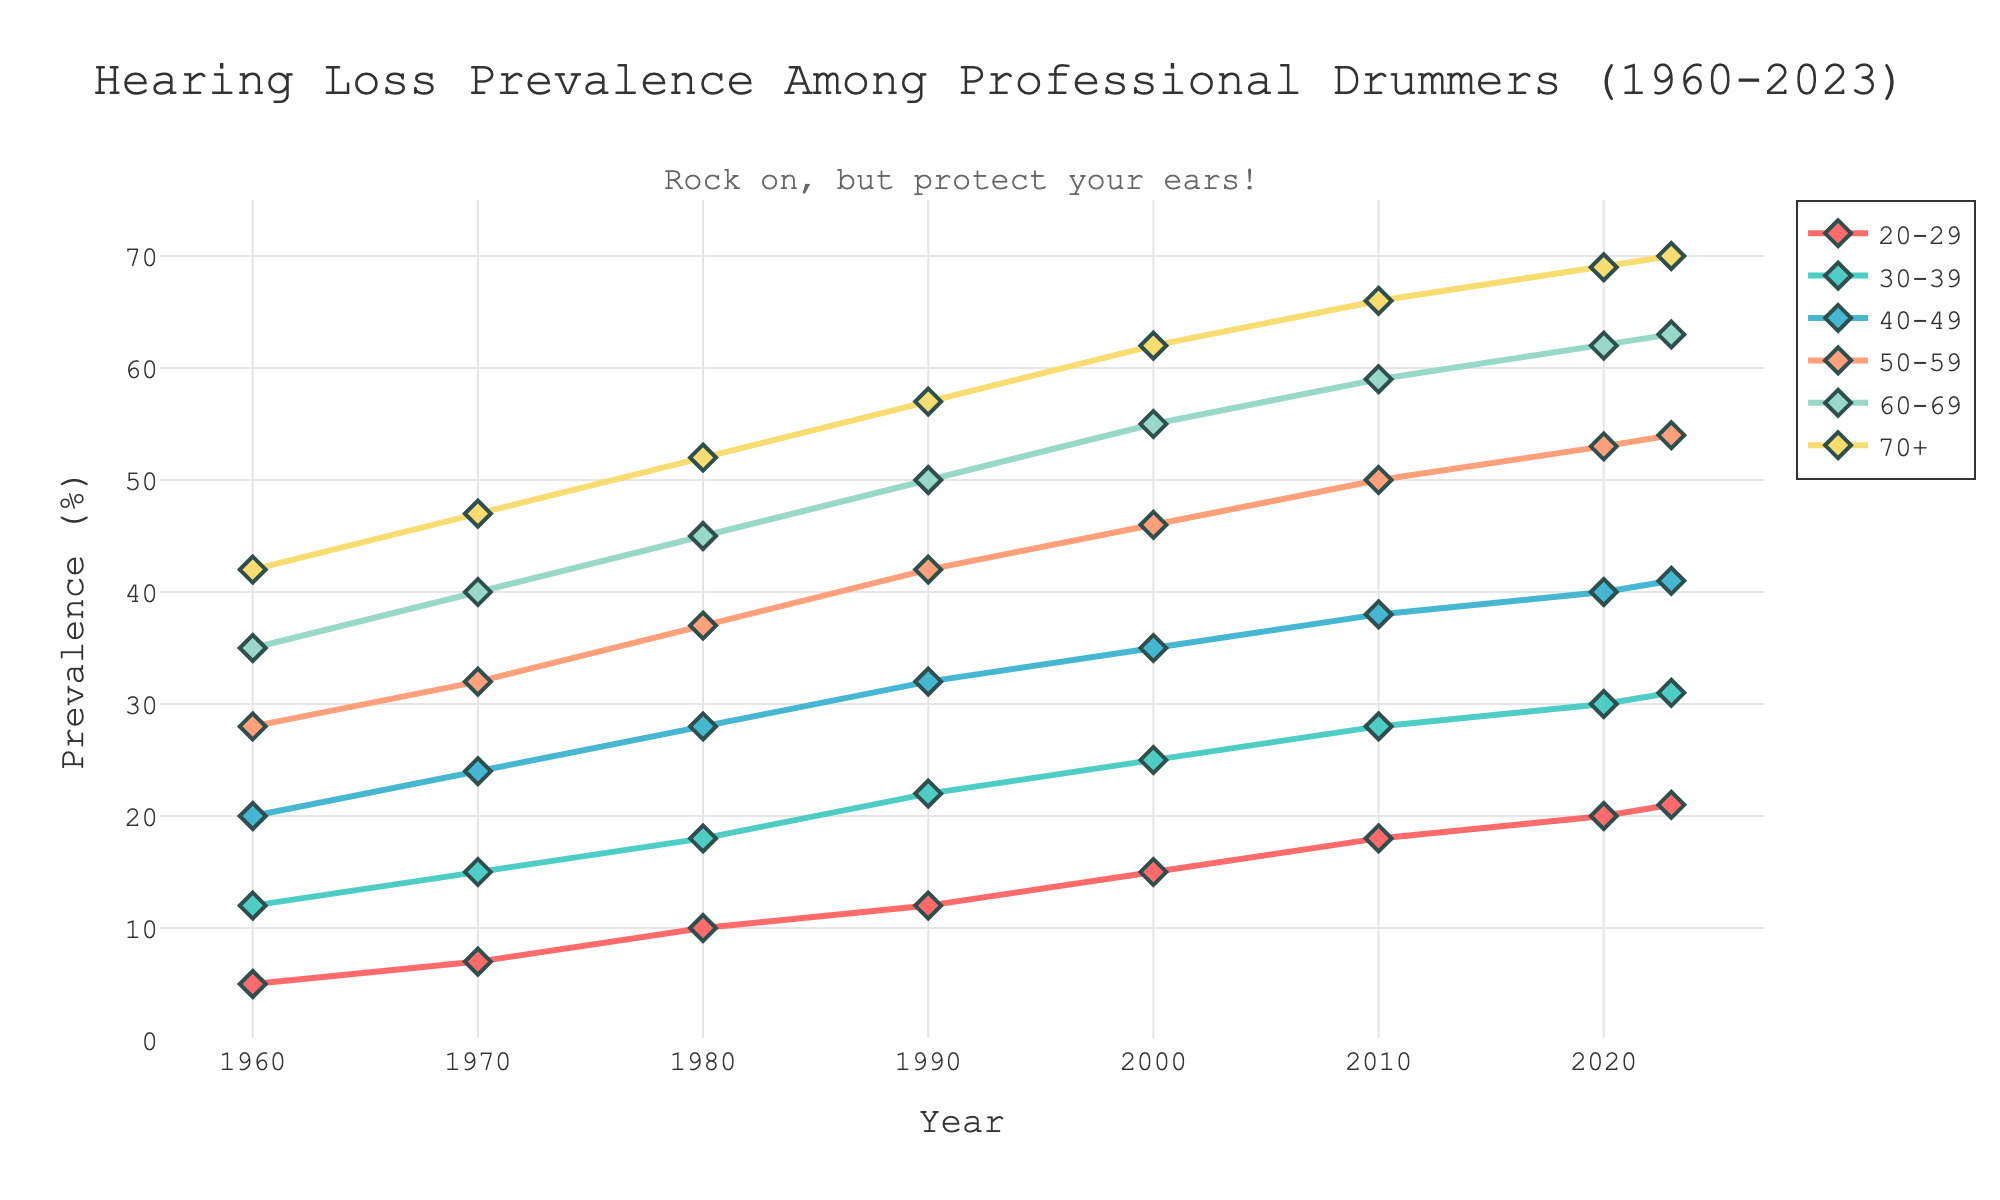How has the prevalence of hearing loss among professional drummers aged 40-49 changed from 1960 to 2023? Observing the line for the age group 40-49, in 1960, the prevalence was 20%. By 2023, it increased to 41%. The change is 41% - 20% = 21%.
Answer: Increased by 21% In which year did professional drummers aged 30-39 experience a prevalence of hearing loss of 25%? Looking at the plot, the data point for 30-39 indicates 25% in the year 2000.
Answer: 2000 Which age group has the highest prevalence of hearing loss in 2023? The points representing data for 2023 indicate that the age group 70+ has the highest prevalence at 70%.
Answer: 70+ What is the difference in the prevalence of hearing loss between the 20-29 and 60-69 age groups in 2010? From the plot, the prevalence for 20-29 in 2010 is 18%, and for 60-69, it is 59%. The difference is 59% - 18% = 41%.
Answer: 41% What is the average prevalence of hearing loss for the age group 50-59 from 1960 to 2023? Using the data: (28+32+37+42+46+50+53+54)/8 = 342/8 = 42.75.
Answer: 42.75% Compare the prevalence of hearing loss among professional drummers aged 40-49 and 50-59 in 1980. Which group had higher prevalence and by how much? In 1980, the prevalence for 40-49 was 28% and for 50-59 was 37%. The group 50-59 had a higher prevalence by 37% - 28% = 9%.
Answer: 50-59 by 9% Which age group has shown the most significant increase in hearing loss prevalence from 1960 to 2023, and what is the increase? Calculating for each group:
- 20-29: 21% - 5% = 16%
- 30-39: 31% - 12% = 19%
- 40-49: 41% - 20% = 21%
- 50-59: 54% - 28% = 26%
- 60-69: 63% - 35% = 28% 
- 70+: 70% - 42% = 28%
The age groups 60-69 and 70+ have the most significant increase at 28%.
Answer: 60-69 and 70+ by 28% During which decade did the age group 70+ experience the most substantial increase in hearing loss prevalence? By checking the increments: 
- 1960 to 1970: 47% - 42% = 5%
- 1970 to 1980: 52% - 47% = 5%
- 1980 to 1990: 57% - 52% = 5%
- 1990 to 2000: 62% - 57% = 5%
- 2000 to 2010: 66% - 62% = 4%
- 2010 to 2020: 69% - 66% = 3%
- 2020 to 2023: 70% - 69% = 1%
The increases are primarily equal, except 2000-2010 has a 4% increase.
Answer: 2000-2010 What is the midpoint prevalence of hearing loss for the 60-69 age group in 1990 and 2000? The prevalence in 1990 for the 60-69 age group is 50%, and in 2000 it is 55%. The midpoint is (50% + 55%) / 2 = 52.5%.
Answer: 52.5% 